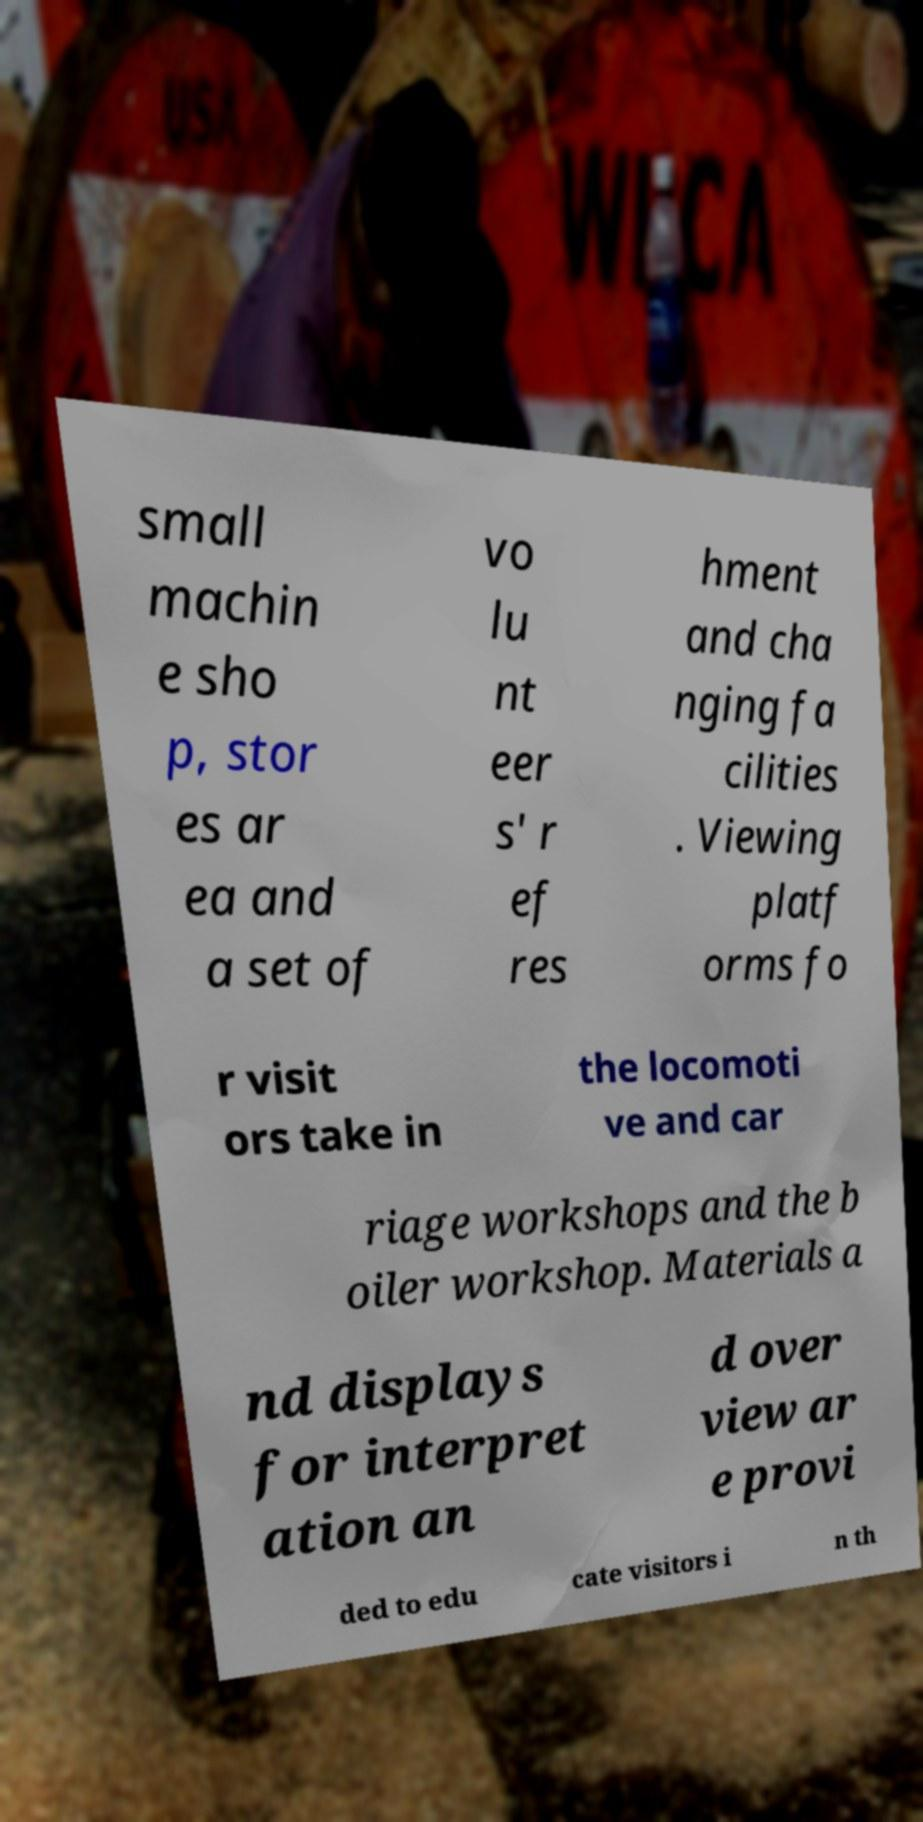Please identify and transcribe the text found in this image. small machin e sho p, stor es ar ea and a set of vo lu nt eer s' r ef res hment and cha nging fa cilities . Viewing platf orms fo r visit ors take in the locomoti ve and car riage workshops and the b oiler workshop. Materials a nd displays for interpret ation an d over view ar e provi ded to edu cate visitors i n th 